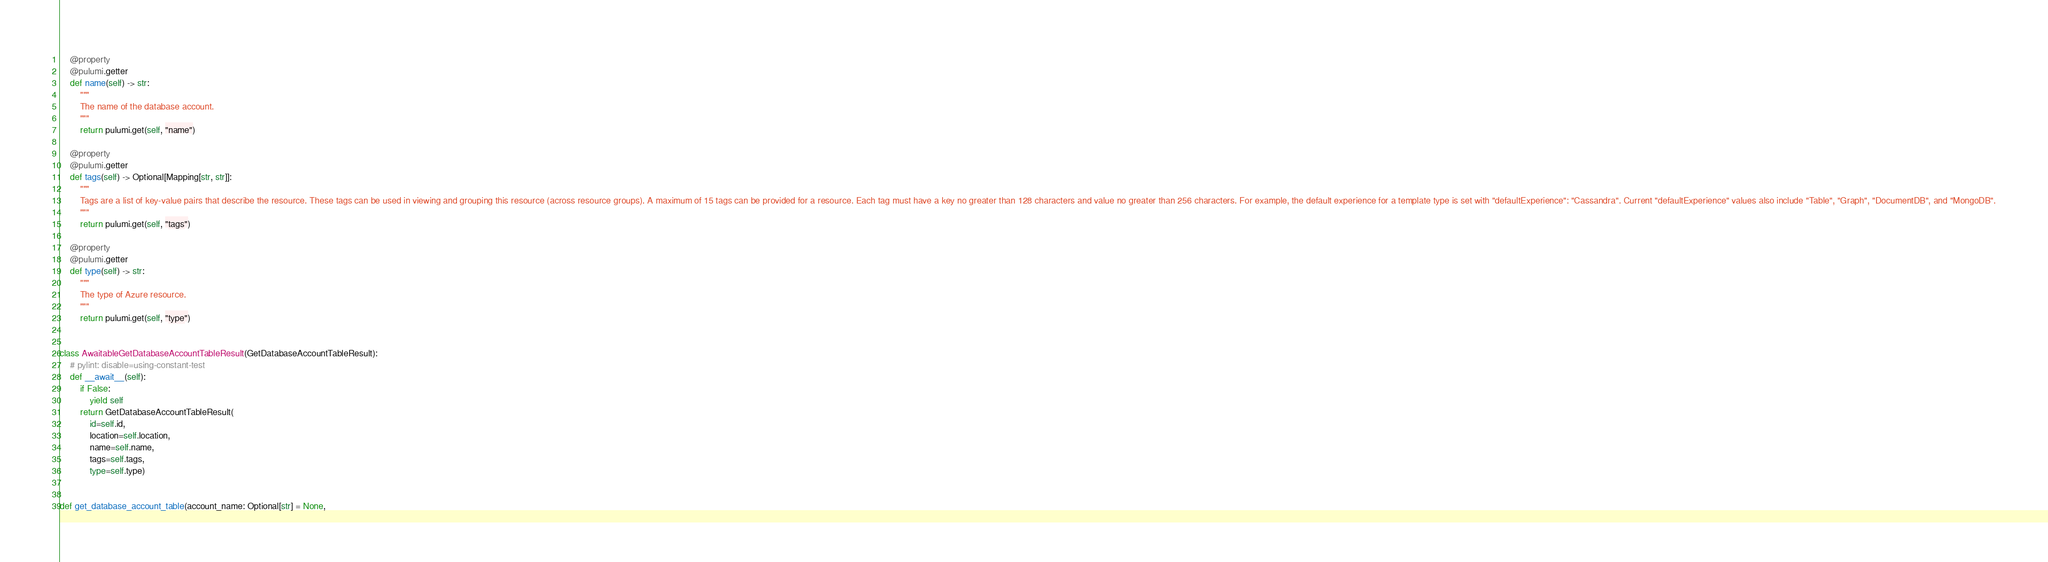Convert code to text. <code><loc_0><loc_0><loc_500><loc_500><_Python_>    @property
    @pulumi.getter
    def name(self) -> str:
        """
        The name of the database account.
        """
        return pulumi.get(self, "name")

    @property
    @pulumi.getter
    def tags(self) -> Optional[Mapping[str, str]]:
        """
        Tags are a list of key-value pairs that describe the resource. These tags can be used in viewing and grouping this resource (across resource groups). A maximum of 15 tags can be provided for a resource. Each tag must have a key no greater than 128 characters and value no greater than 256 characters. For example, the default experience for a template type is set with "defaultExperience": "Cassandra". Current "defaultExperience" values also include "Table", "Graph", "DocumentDB", and "MongoDB".
        """
        return pulumi.get(self, "tags")

    @property
    @pulumi.getter
    def type(self) -> str:
        """
        The type of Azure resource.
        """
        return pulumi.get(self, "type")


class AwaitableGetDatabaseAccountTableResult(GetDatabaseAccountTableResult):
    # pylint: disable=using-constant-test
    def __await__(self):
        if False:
            yield self
        return GetDatabaseAccountTableResult(
            id=self.id,
            location=self.location,
            name=self.name,
            tags=self.tags,
            type=self.type)


def get_database_account_table(account_name: Optional[str] = None,</code> 